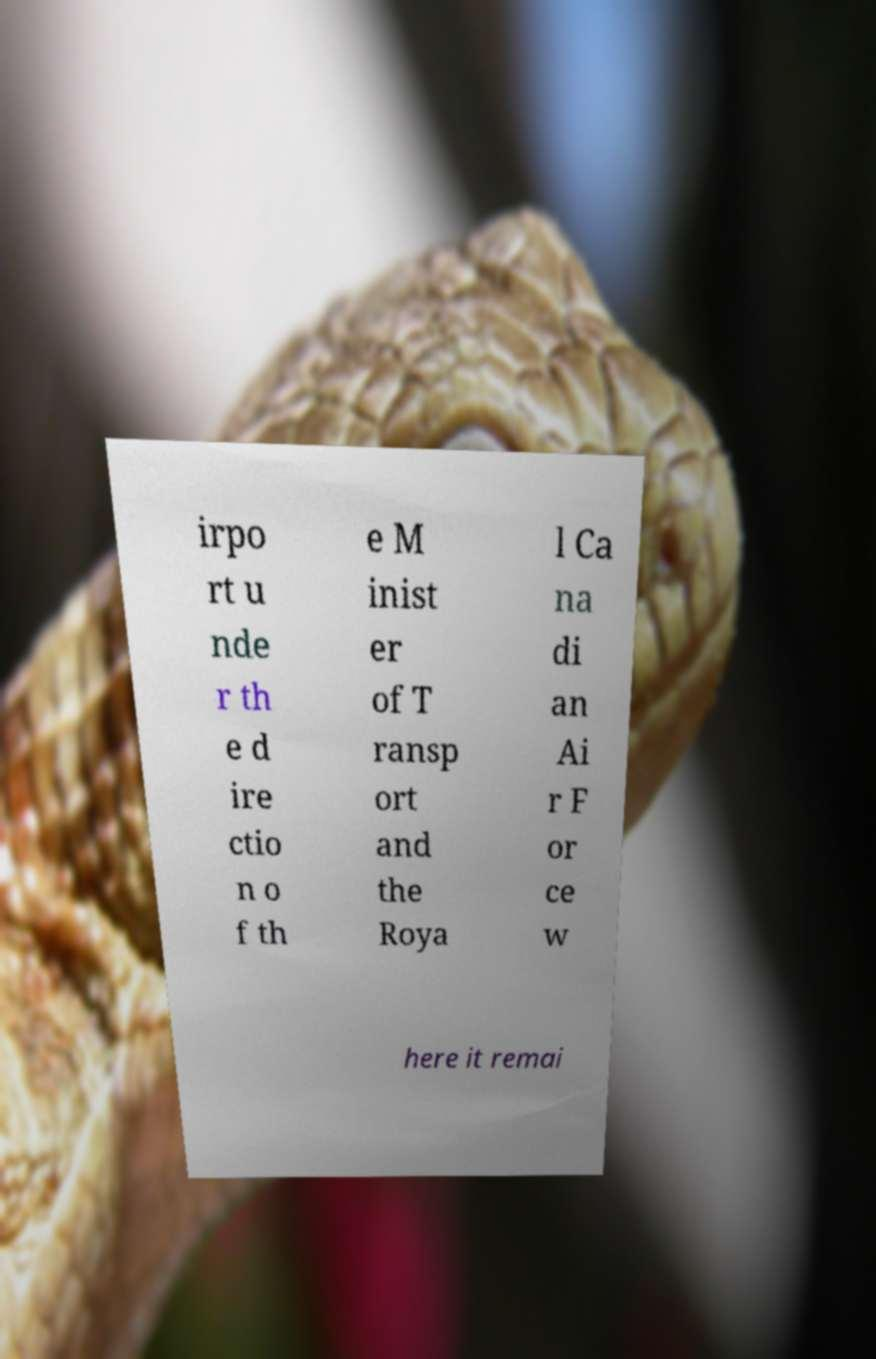There's text embedded in this image that I need extracted. Can you transcribe it verbatim? irpo rt u nde r th e d ire ctio n o f th e M inist er of T ransp ort and the Roya l Ca na di an Ai r F or ce w here it remai 